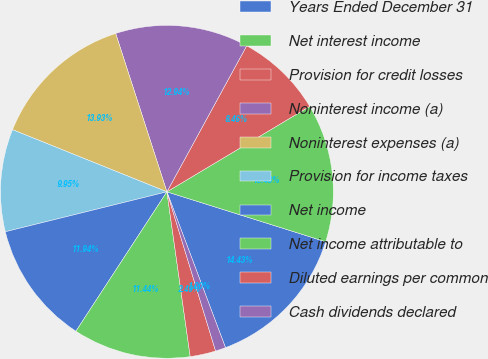Convert chart to OTSL. <chart><loc_0><loc_0><loc_500><loc_500><pie_chart><fcel>Years Ended December 31<fcel>Net interest income<fcel>Provision for credit losses<fcel>Noninterest income (a)<fcel>Noninterest expenses (a)<fcel>Provision for income taxes<fcel>Net income<fcel>Net income attributable to<fcel>Diluted earnings per common<fcel>Cash dividends declared<nl><fcel>14.43%<fcel>13.43%<fcel>8.46%<fcel>12.94%<fcel>13.93%<fcel>9.95%<fcel>11.94%<fcel>11.44%<fcel>2.49%<fcel>1.0%<nl></chart> 